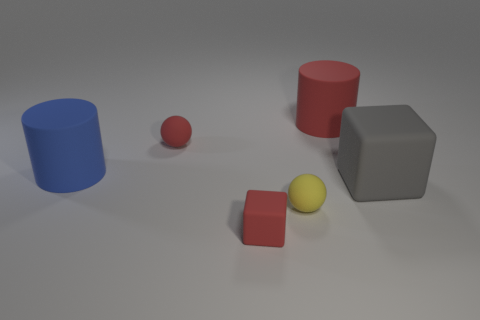Add 2 tiny red matte spheres. How many objects exist? 8 Subtract all cylinders. How many objects are left? 4 Add 5 big red cylinders. How many big red cylinders exist? 6 Subtract 0 gray balls. How many objects are left? 6 Subtract all small yellow matte spheres. Subtract all red things. How many objects are left? 2 Add 6 large rubber things. How many large rubber things are left? 9 